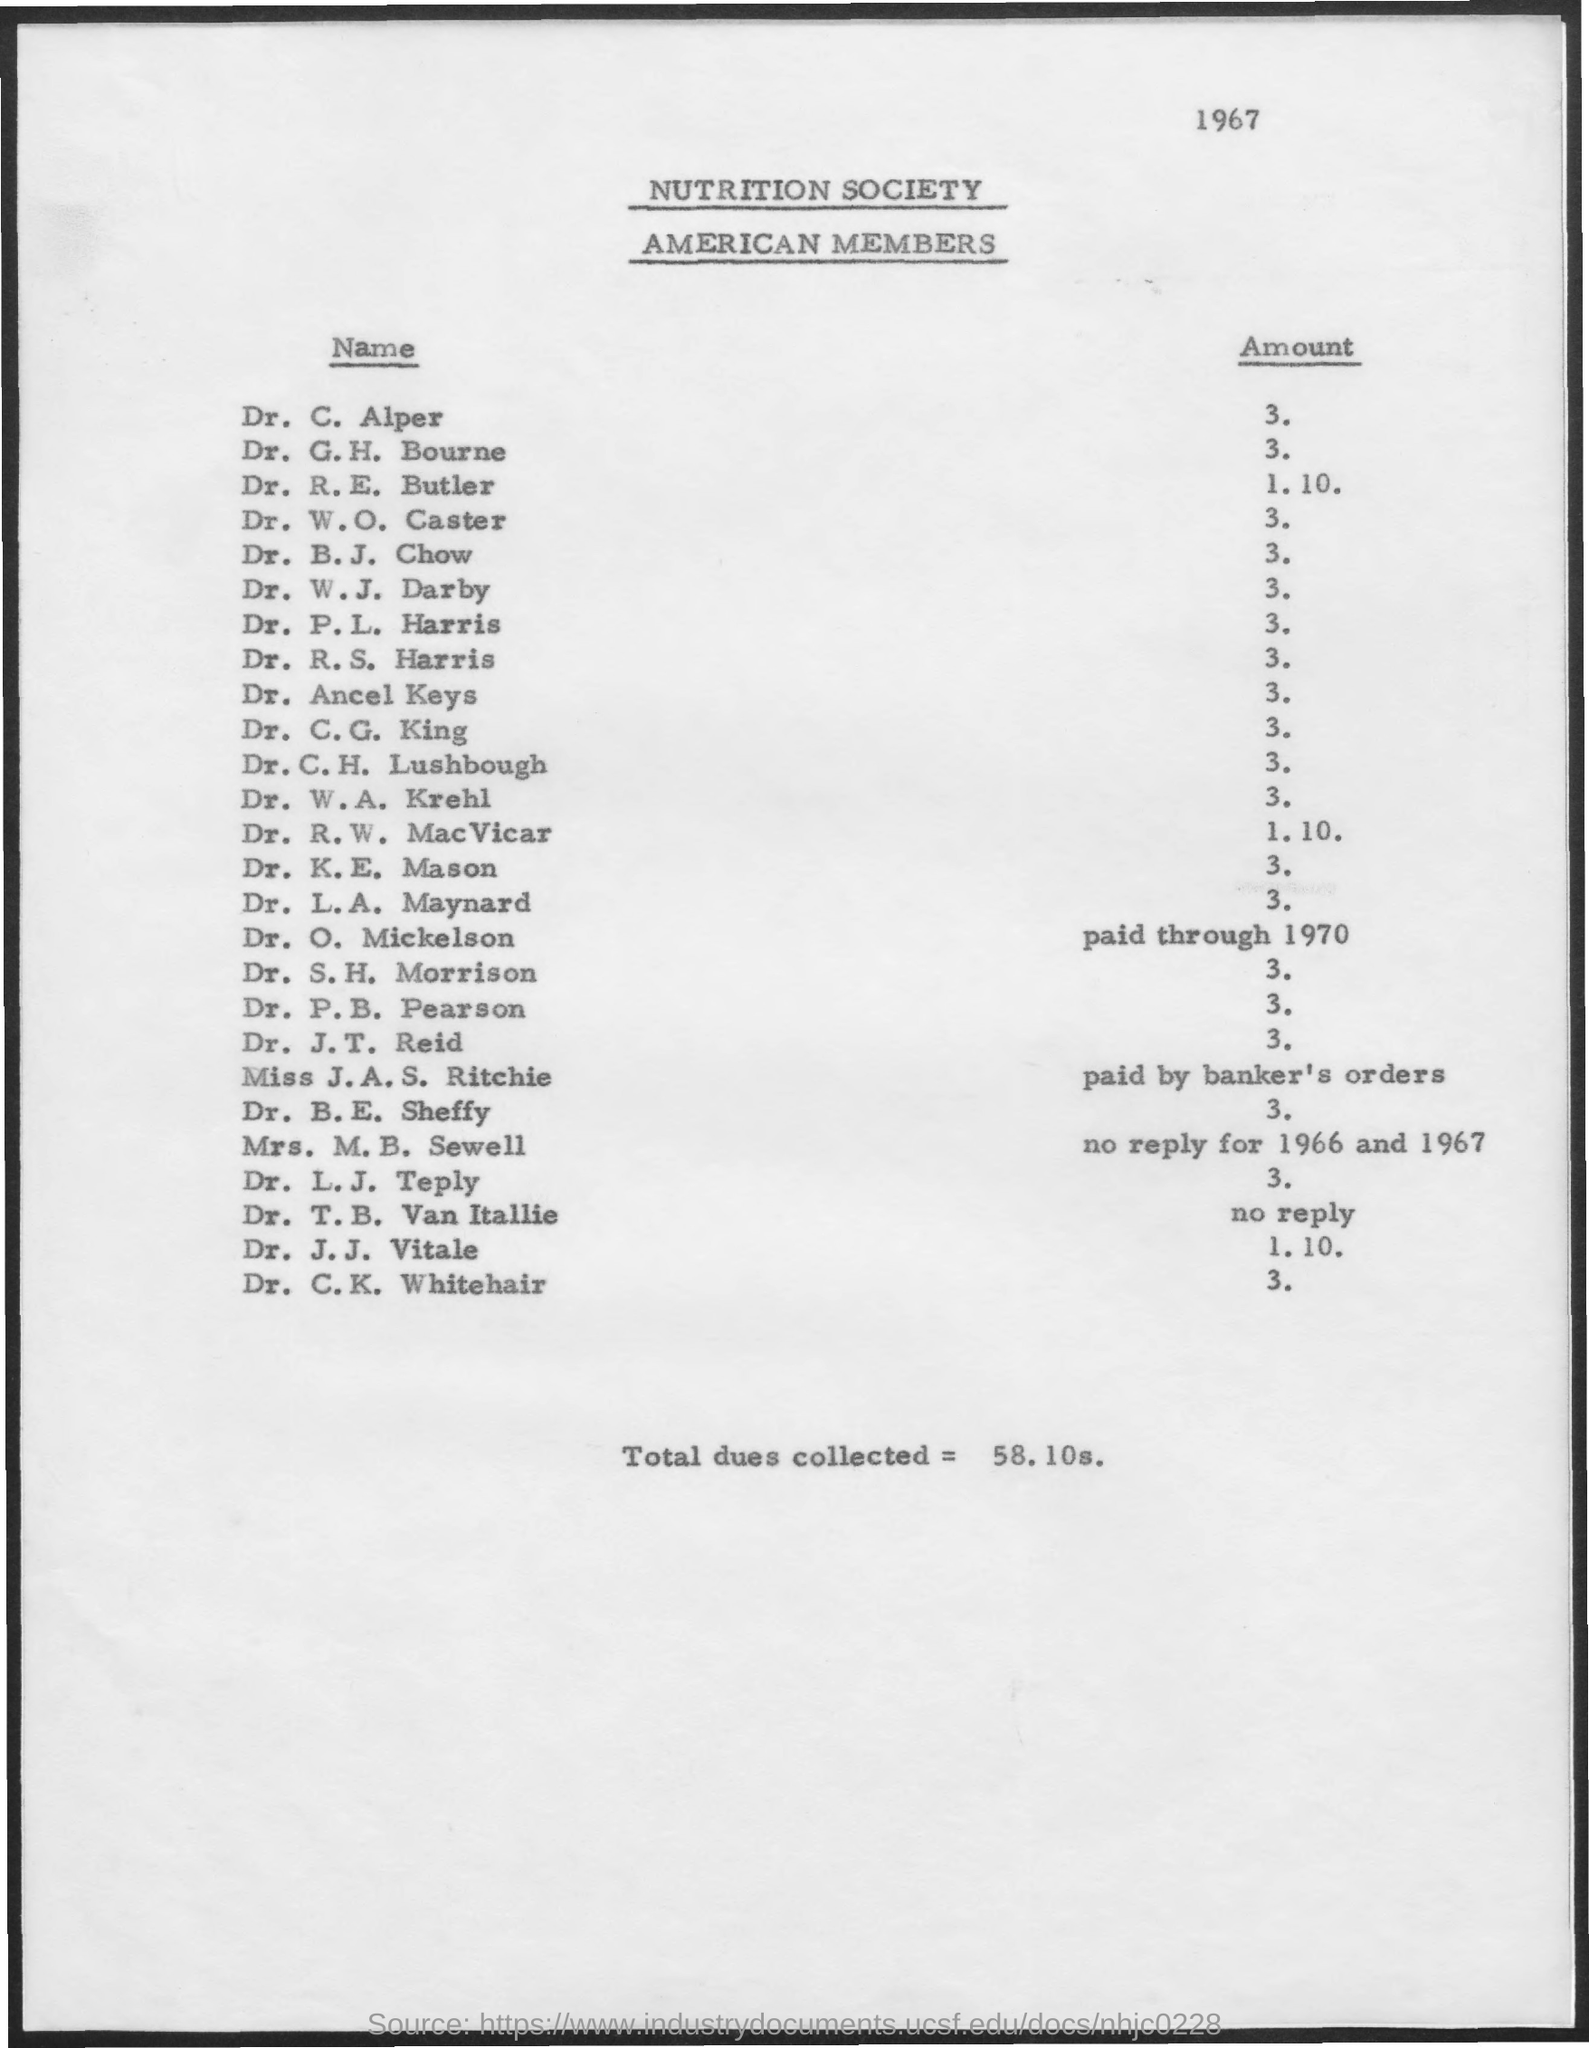What is the year mentioned on the top of the page
Provide a succinct answer. 1967. How much is the total dues collected ?
Offer a very short reply. 58.10s. What is the name of the society mentioned ?
Keep it short and to the point. Nutrition society. How much is the amount for dr. c. alper
Make the answer very short. 3. How much is the amount for dr. c.g. king
Keep it short and to the point. 3. 